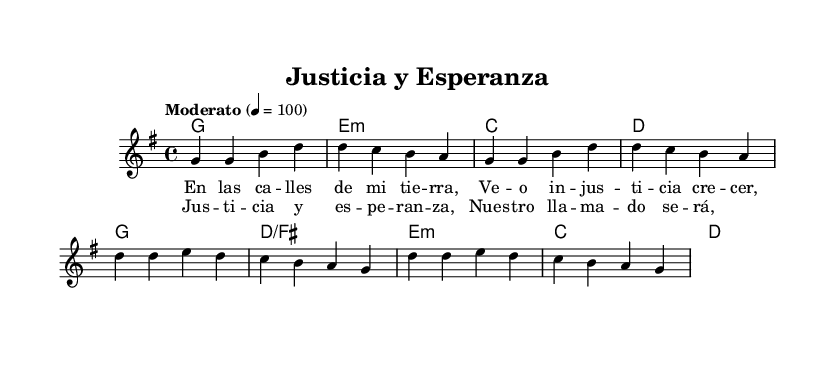What is the key signature of this music? The music is in the key of G major, which is indicated by the presence of one sharp (F#) in the key signature.
Answer: G major What is the time signature of this music? The time signature shown is 4/4, which means there are four beats in a measure and the quarter note receives one beat.
Answer: 4/4 What is the tempo marking for this piece? The tempo is indicated as "Moderato" at a speed of 100 beats per minute, suggesting a moderate and steady pace for the performance.
Answer: Moderato, 100 How many measures are in the verse? The verse consists of four measures, each of which is represented in the sheet music with a sequence of notes and rests.
Answer: 4 What type of chords are used in the verse? The chords in the verse are G major, E minor, C major, and D major, which are often found in praise and worship music, supporting the melody.
Answer: G, E minor, C, D What message does the chorus emphasize? The chorus emphasizes the themes of "Justice and Hope," as explicitly stated in the lyrics, highlighting social justice issues and aspirations in the context of praise music.
Answer: Justicia y esperanza What social issue is mentioned in the verse? The verse addresses "injustice" as a social issue that is recognized and highlighted through the lyrics, reflecting the importance of awareness and action.
Answer: Injusticia 